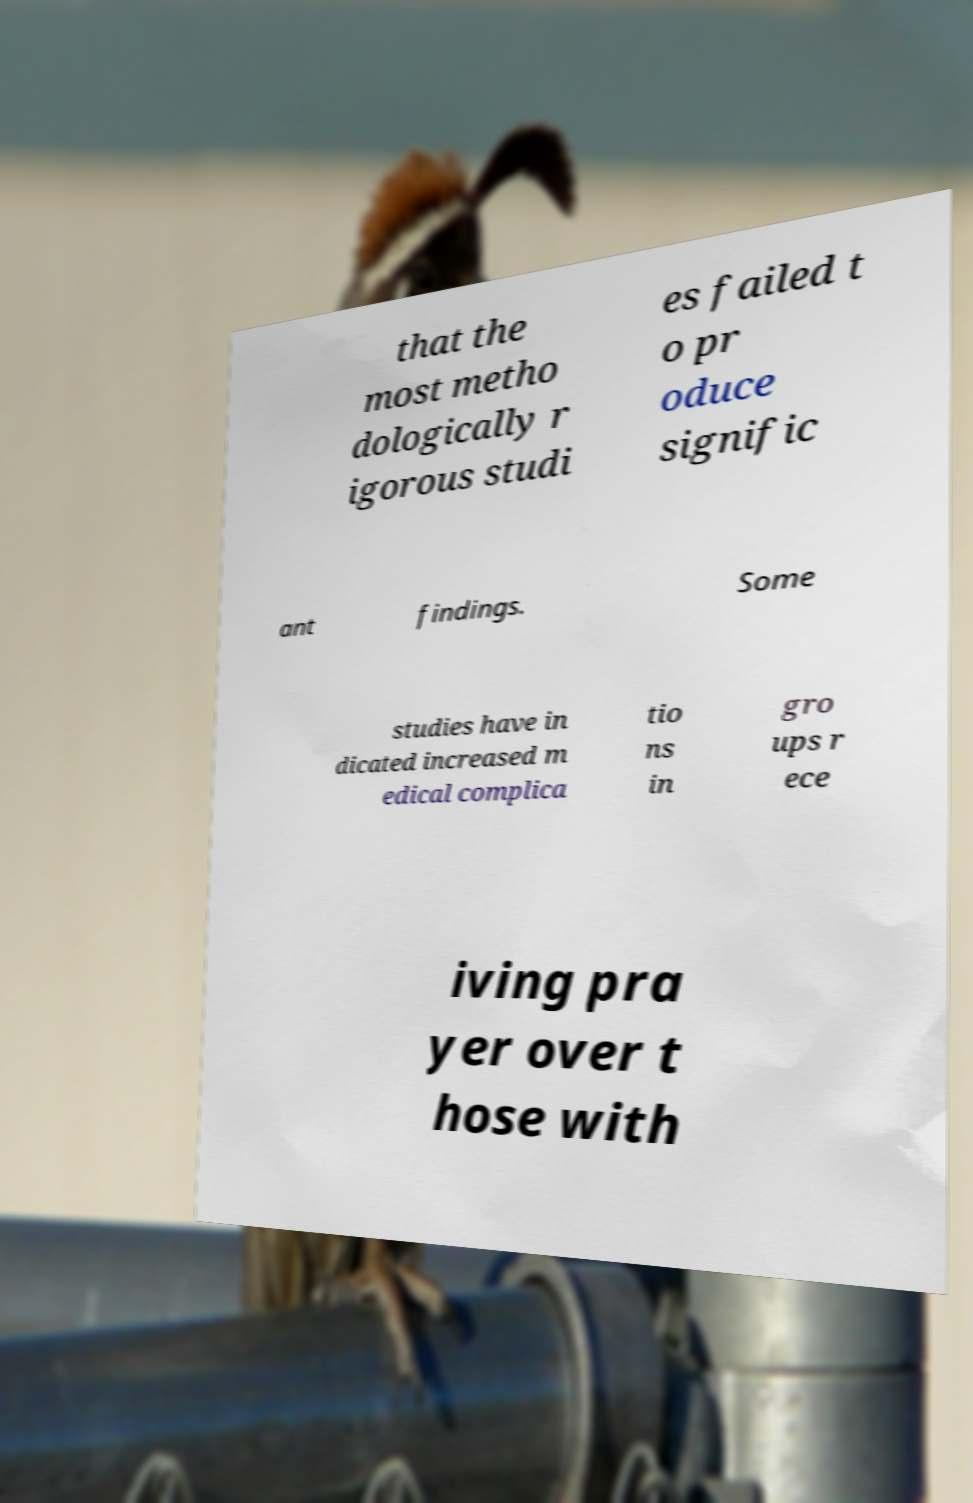Please read and relay the text visible in this image. What does it say? that the most metho dologically r igorous studi es failed t o pr oduce signific ant findings. Some studies have in dicated increased m edical complica tio ns in gro ups r ece iving pra yer over t hose with 